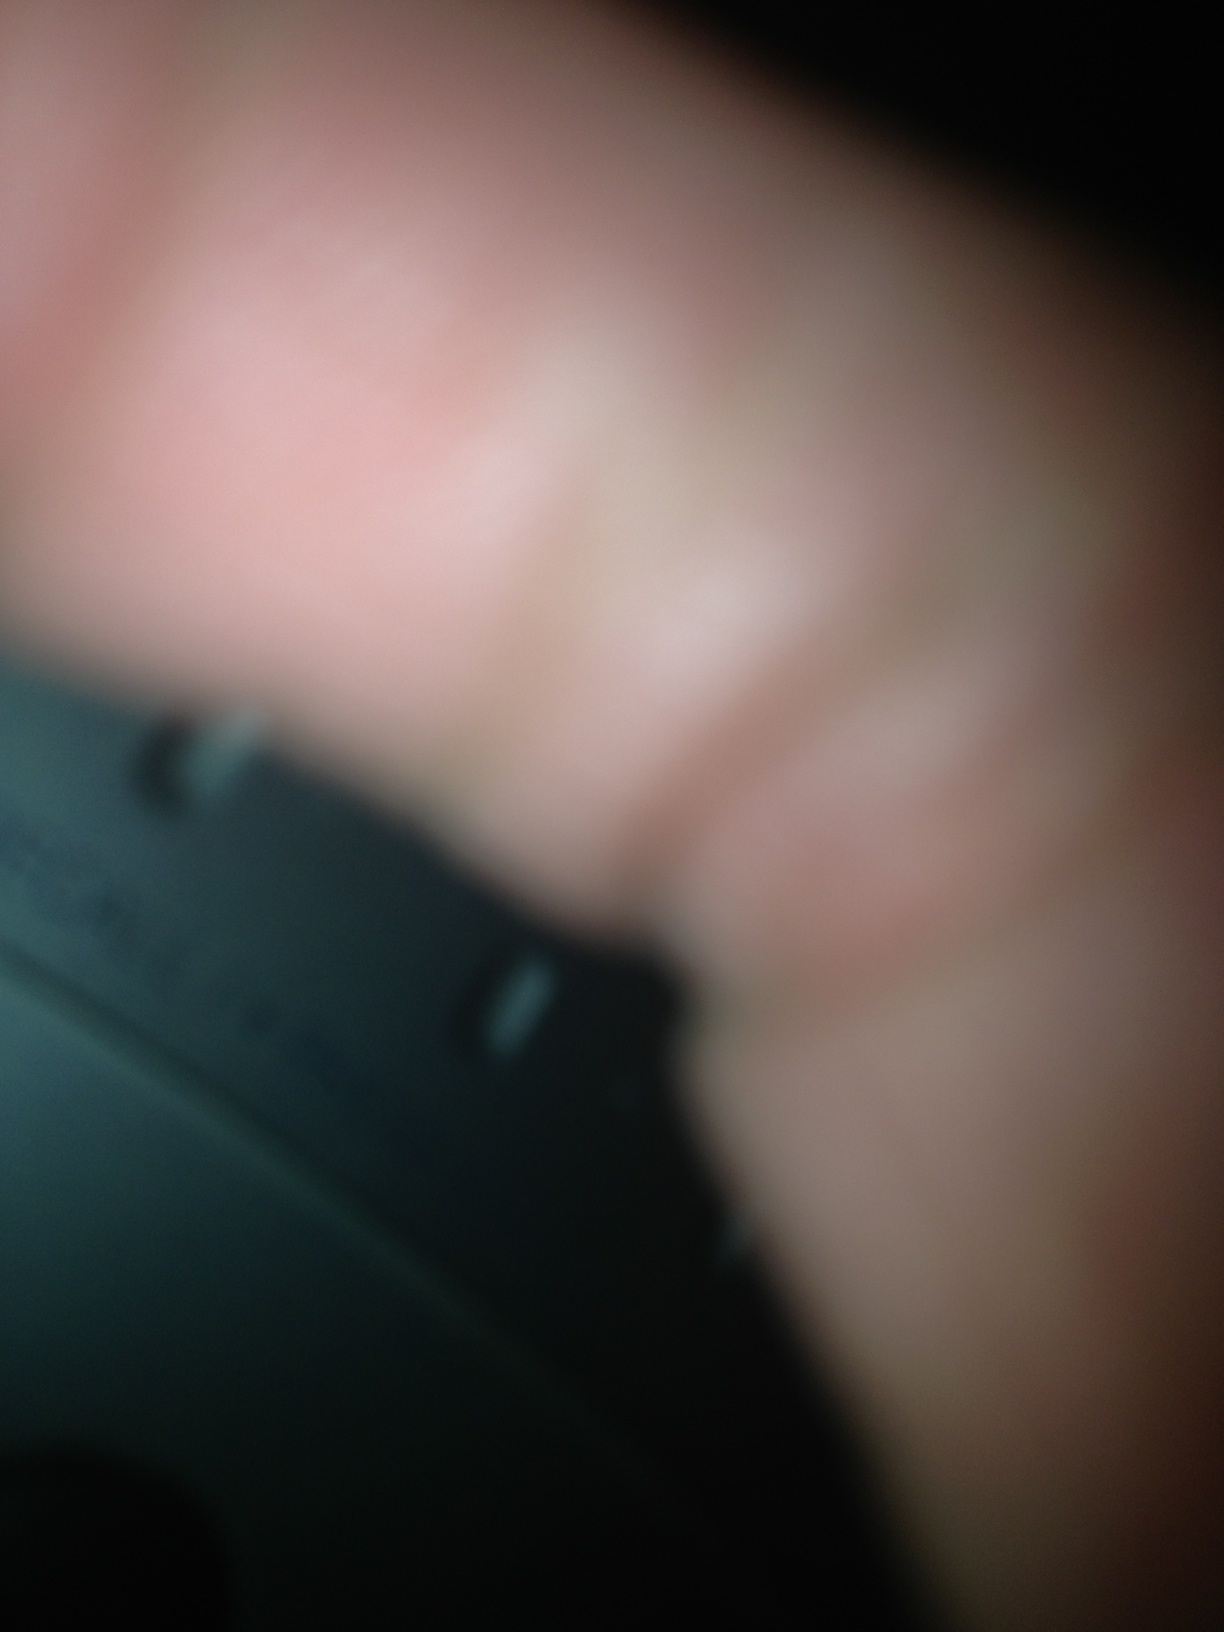What fictional story can you come up with involving this image? In a world where technology has surpassed the boundaries of imagination, a secret organization developed an ultra-small supercomputer capable of changing the world. This device, however, could only be seen by those who dare to look at it through the blur of uncertainty. The blurry image you see is not a mere radio artifact; it's the front panel of the supercomputer known as the 'Oracle's Code'. With a slight turn of its dials, one could predict the future, altering the fabric of reality itself. The existence of this device remained hidden from the world, only coming into focus for the chosen ones, those who could decipher the blurriness of life and see through to the truth. 